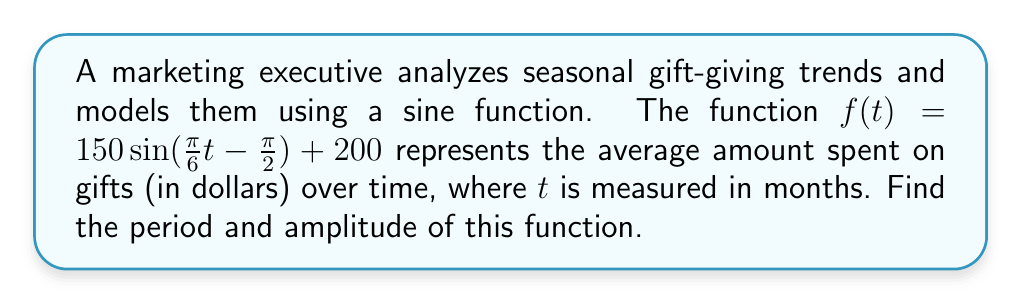What is the answer to this math problem? To find the period and amplitude of the sine function, we need to analyze its general form:

$$f(t) = A \sin(B(t - C)) + D$$

Where:
- $A$ is the amplitude
- $B$ determines the period
- $C$ is the phase shift
- $D$ is the vertical shift

In our function: $f(t) = 150 \sin(\frac{\pi}{6}t - \frac{\pi}{2}) + 200$

Step 1: Identify the amplitude
The amplitude is the coefficient of the sine function, which is 150.

Step 2: Find the period
The period of a sine function is given by the formula:

$$\text{Period} = \frac{2\pi}{|B|}$$

In our case, $B = \frac{\pi}{6}$

Therefore, the period is:

$$\text{Period} = \frac{2\pi}{|\frac{\pi}{6}|} = \frac{2\pi}{\frac{\pi}{6}} = 2 \cdot 6 = 12$$

The period is 12 months, which makes sense for annual gift-giving trends.

Step 3: Verify the units
The period is in months, which aligns with our time variable $t$ being measured in months.

The amplitude is in dollars, which matches the function's output of average amount spent on gifts.
Answer: Period: 12 months, Amplitude: $150 